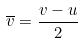<formula> <loc_0><loc_0><loc_500><loc_500>\overline { v } = \frac { v - u } { 2 }</formula> 